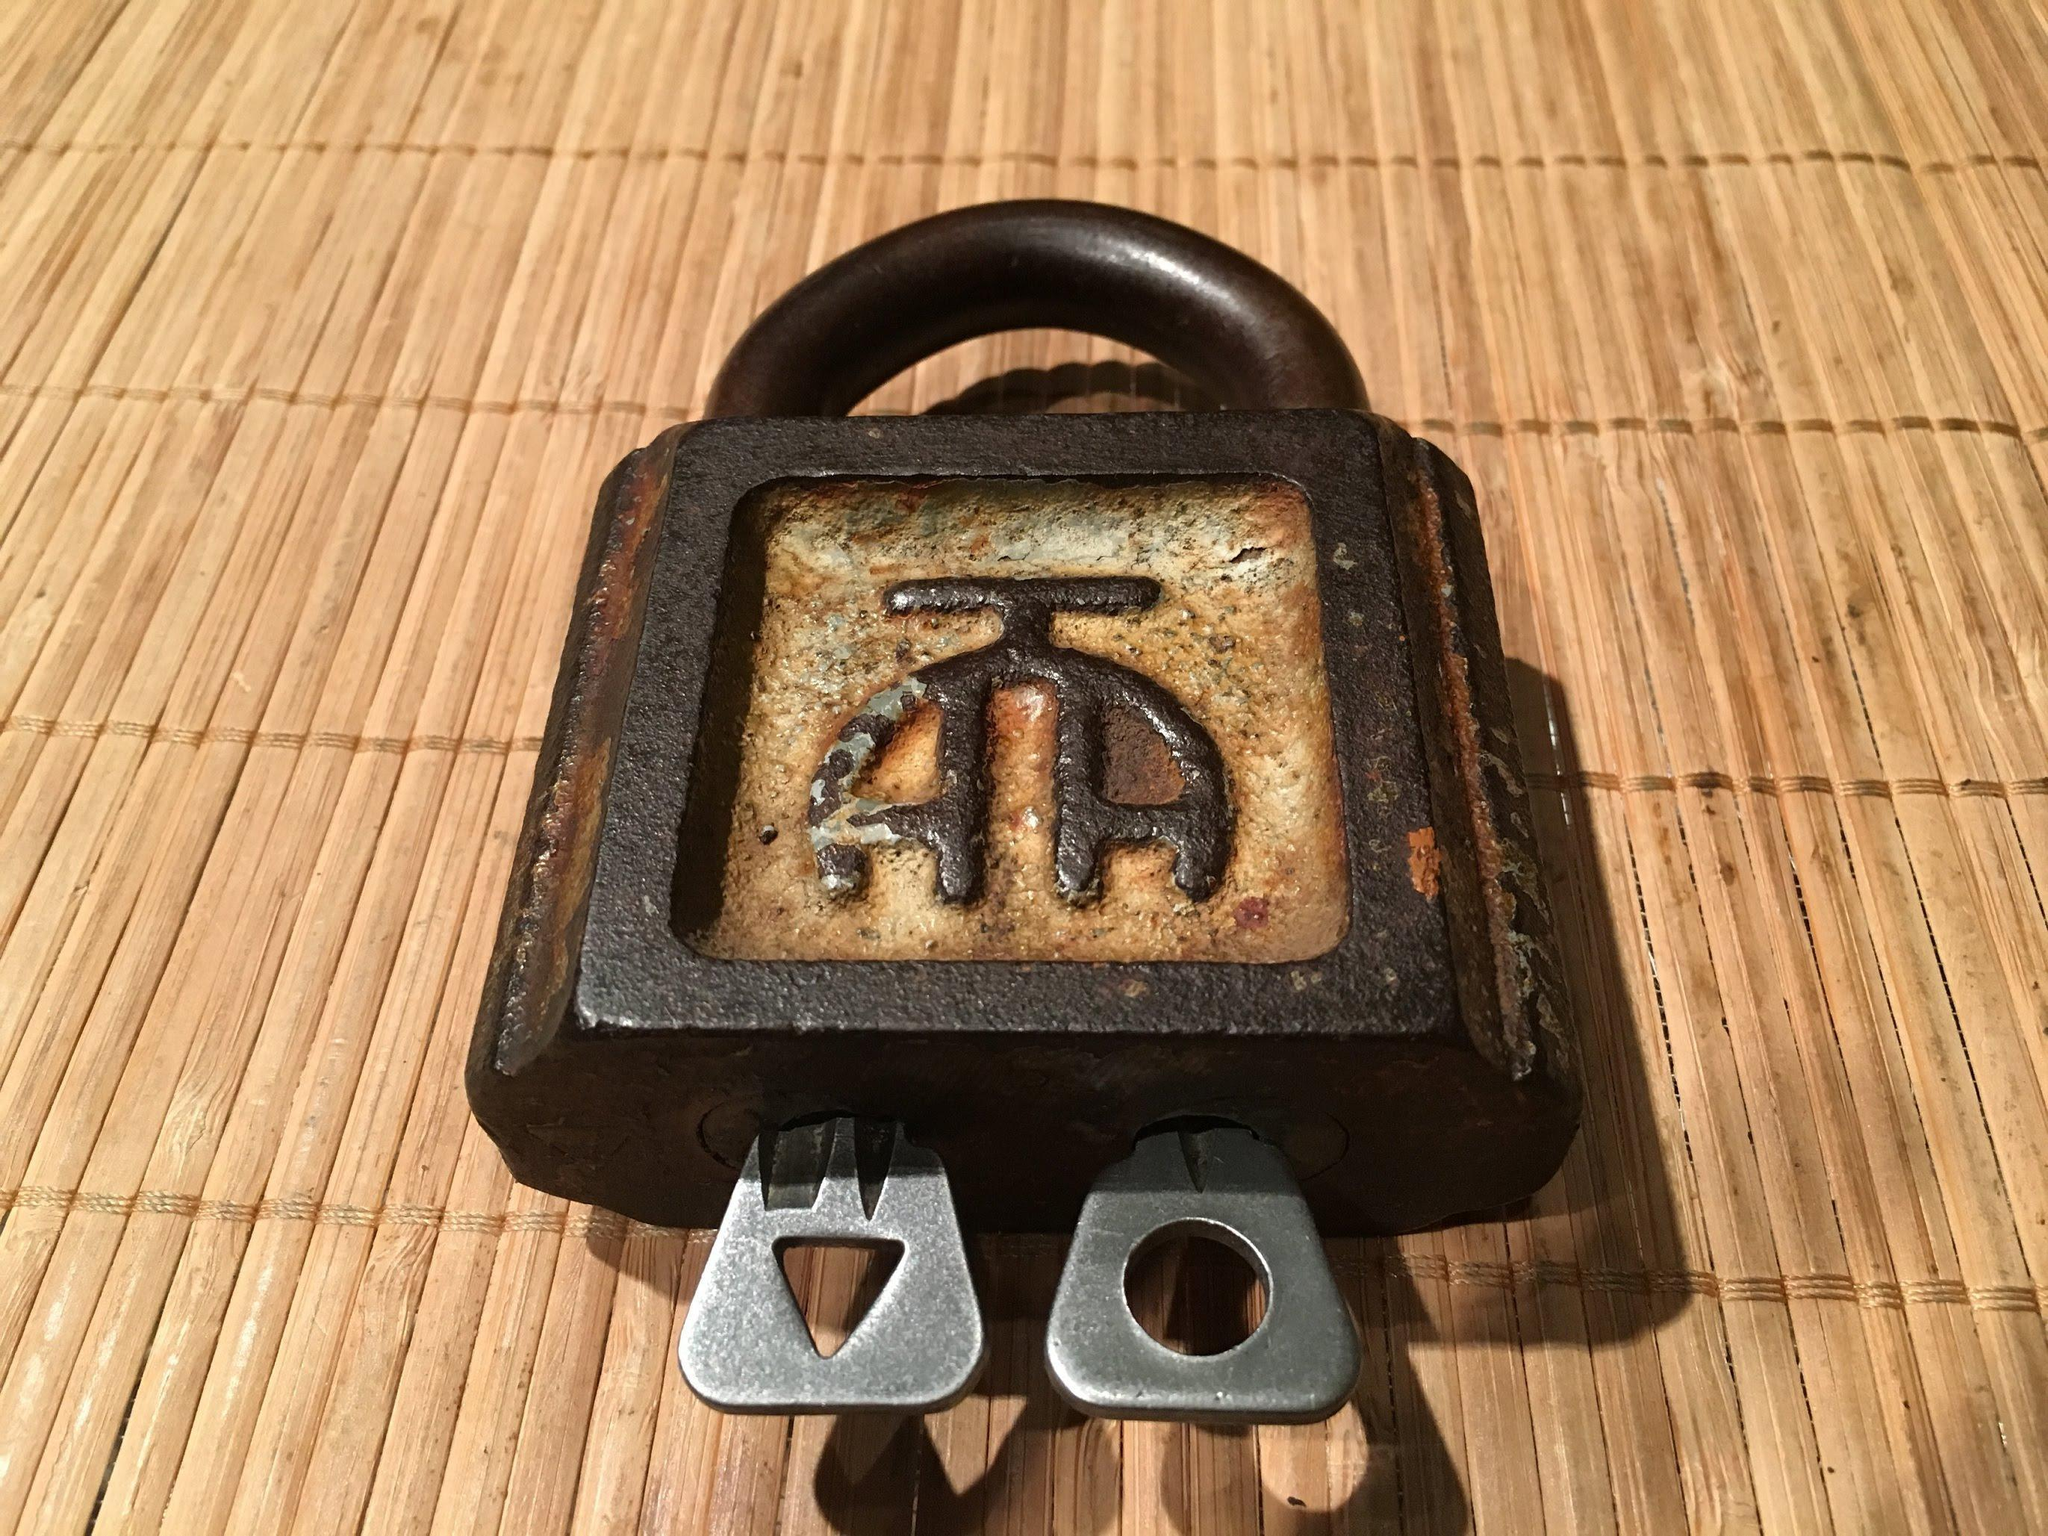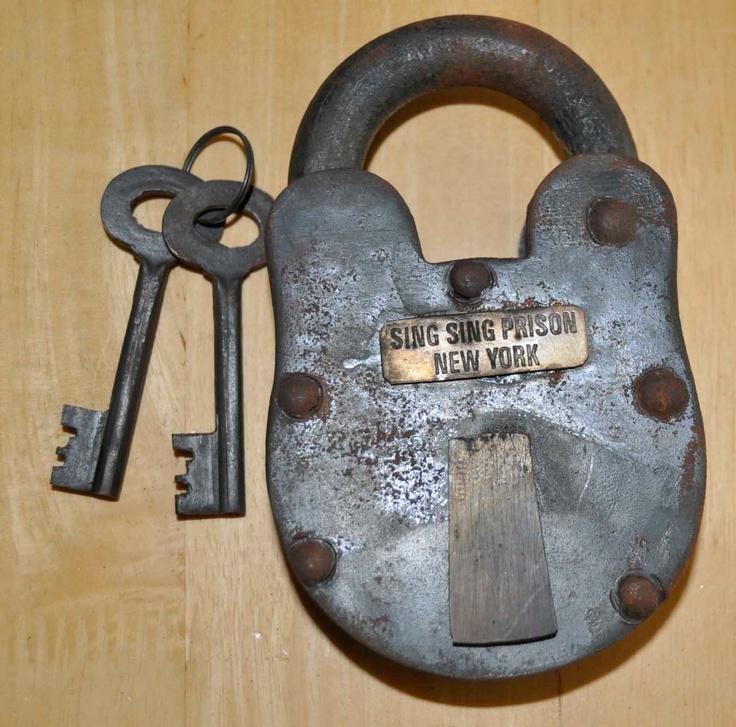The first image is the image on the left, the second image is the image on the right. Assess this claim about the two images: "An image shows one lock with two keys inserted into it.". Correct or not? Answer yes or no. Yes. The first image is the image on the left, the second image is the image on the right. Examine the images to the left and right. Is the description "There is at least one lock with the key inside the locking mechanism in the right image." accurate? Answer yes or no. No. 